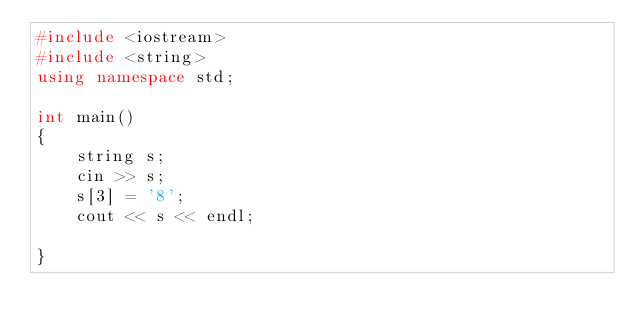Convert code to text. <code><loc_0><loc_0><loc_500><loc_500><_C++_>#include <iostream>
#include <string>
using namespace std;

int main()
{
    string s;
    cin >> s;
    s[3] = '8';
    cout << s << endl;

}</code> 